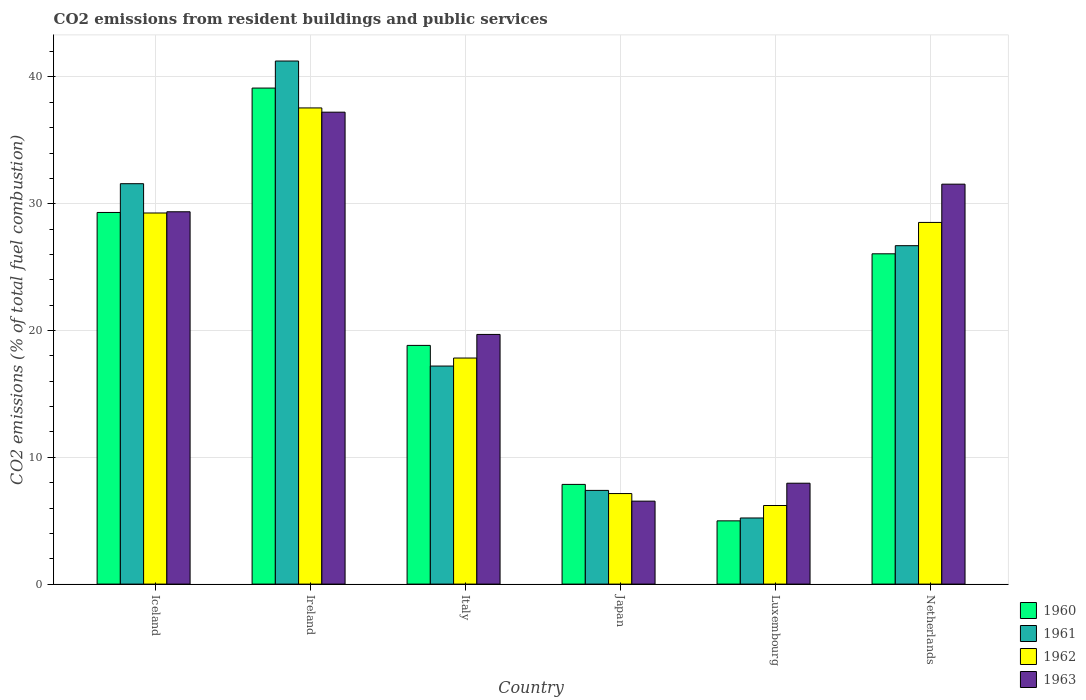How many different coloured bars are there?
Make the answer very short. 4. Are the number of bars per tick equal to the number of legend labels?
Keep it short and to the point. Yes. How many bars are there on the 4th tick from the left?
Provide a succinct answer. 4. What is the label of the 3rd group of bars from the left?
Your answer should be compact. Italy. What is the total CO2 emitted in 1960 in Luxembourg?
Your answer should be compact. 4.99. Across all countries, what is the maximum total CO2 emitted in 1961?
Make the answer very short. 41.25. Across all countries, what is the minimum total CO2 emitted in 1962?
Give a very brief answer. 6.2. In which country was the total CO2 emitted in 1963 maximum?
Offer a very short reply. Ireland. In which country was the total CO2 emitted in 1963 minimum?
Your answer should be compact. Japan. What is the total total CO2 emitted in 1962 in the graph?
Offer a very short reply. 126.52. What is the difference between the total CO2 emitted in 1962 in Iceland and that in Italy?
Your answer should be compact. 11.44. What is the difference between the total CO2 emitted in 1961 in Netherlands and the total CO2 emitted in 1962 in Luxembourg?
Ensure brevity in your answer.  20.49. What is the average total CO2 emitted in 1963 per country?
Make the answer very short. 22.05. What is the difference between the total CO2 emitted of/in 1963 and total CO2 emitted of/in 1960 in Netherlands?
Your answer should be very brief. 5.49. What is the ratio of the total CO2 emitted in 1961 in Ireland to that in Luxembourg?
Offer a terse response. 7.91. Is the difference between the total CO2 emitted in 1963 in Italy and Japan greater than the difference between the total CO2 emitted in 1960 in Italy and Japan?
Provide a succinct answer. Yes. What is the difference between the highest and the second highest total CO2 emitted in 1962?
Ensure brevity in your answer.  0.74. What is the difference between the highest and the lowest total CO2 emitted in 1962?
Your answer should be very brief. 31.36. In how many countries, is the total CO2 emitted in 1963 greater than the average total CO2 emitted in 1963 taken over all countries?
Offer a very short reply. 3. Is the sum of the total CO2 emitted in 1960 in Italy and Japan greater than the maximum total CO2 emitted in 1961 across all countries?
Make the answer very short. No. What does the 2nd bar from the right in Netherlands represents?
Offer a terse response. 1962. Are all the bars in the graph horizontal?
Offer a very short reply. No. How many countries are there in the graph?
Your response must be concise. 6. What is the difference between two consecutive major ticks on the Y-axis?
Your answer should be very brief. 10. Are the values on the major ticks of Y-axis written in scientific E-notation?
Keep it short and to the point. No. Does the graph contain any zero values?
Offer a terse response. No. Does the graph contain grids?
Your answer should be very brief. Yes. How many legend labels are there?
Keep it short and to the point. 4. How are the legend labels stacked?
Offer a very short reply. Vertical. What is the title of the graph?
Offer a terse response. CO2 emissions from resident buildings and public services. What is the label or title of the X-axis?
Offer a terse response. Country. What is the label or title of the Y-axis?
Make the answer very short. CO2 emissions (% of total fuel combustion). What is the CO2 emissions (% of total fuel combustion) of 1960 in Iceland?
Make the answer very short. 29.31. What is the CO2 emissions (% of total fuel combustion) in 1961 in Iceland?
Make the answer very short. 31.58. What is the CO2 emissions (% of total fuel combustion) in 1962 in Iceland?
Your response must be concise. 29.27. What is the CO2 emissions (% of total fuel combustion) of 1963 in Iceland?
Make the answer very short. 29.37. What is the CO2 emissions (% of total fuel combustion) of 1960 in Ireland?
Make the answer very short. 39.12. What is the CO2 emissions (% of total fuel combustion) of 1961 in Ireland?
Your response must be concise. 41.25. What is the CO2 emissions (% of total fuel combustion) of 1962 in Ireland?
Ensure brevity in your answer.  37.55. What is the CO2 emissions (% of total fuel combustion) in 1963 in Ireland?
Offer a very short reply. 37.22. What is the CO2 emissions (% of total fuel combustion) in 1960 in Italy?
Offer a terse response. 18.83. What is the CO2 emissions (% of total fuel combustion) in 1961 in Italy?
Keep it short and to the point. 17.2. What is the CO2 emissions (% of total fuel combustion) of 1962 in Italy?
Your answer should be compact. 17.83. What is the CO2 emissions (% of total fuel combustion) of 1963 in Italy?
Give a very brief answer. 19.69. What is the CO2 emissions (% of total fuel combustion) of 1960 in Japan?
Your response must be concise. 7.86. What is the CO2 emissions (% of total fuel combustion) in 1961 in Japan?
Ensure brevity in your answer.  7.39. What is the CO2 emissions (% of total fuel combustion) in 1962 in Japan?
Your answer should be very brief. 7.14. What is the CO2 emissions (% of total fuel combustion) in 1963 in Japan?
Give a very brief answer. 6.54. What is the CO2 emissions (% of total fuel combustion) of 1960 in Luxembourg?
Ensure brevity in your answer.  4.99. What is the CO2 emissions (% of total fuel combustion) of 1961 in Luxembourg?
Make the answer very short. 5.21. What is the CO2 emissions (% of total fuel combustion) of 1962 in Luxembourg?
Ensure brevity in your answer.  6.2. What is the CO2 emissions (% of total fuel combustion) in 1963 in Luxembourg?
Your response must be concise. 7.96. What is the CO2 emissions (% of total fuel combustion) of 1960 in Netherlands?
Provide a short and direct response. 26.05. What is the CO2 emissions (% of total fuel combustion) in 1961 in Netherlands?
Keep it short and to the point. 26.69. What is the CO2 emissions (% of total fuel combustion) of 1962 in Netherlands?
Provide a succinct answer. 28.52. What is the CO2 emissions (% of total fuel combustion) in 1963 in Netherlands?
Provide a succinct answer. 31.54. Across all countries, what is the maximum CO2 emissions (% of total fuel combustion) in 1960?
Your answer should be very brief. 39.12. Across all countries, what is the maximum CO2 emissions (% of total fuel combustion) in 1961?
Your answer should be compact. 41.25. Across all countries, what is the maximum CO2 emissions (% of total fuel combustion) in 1962?
Offer a terse response. 37.55. Across all countries, what is the maximum CO2 emissions (% of total fuel combustion) in 1963?
Your answer should be very brief. 37.22. Across all countries, what is the minimum CO2 emissions (% of total fuel combustion) in 1960?
Offer a very short reply. 4.99. Across all countries, what is the minimum CO2 emissions (% of total fuel combustion) in 1961?
Provide a short and direct response. 5.21. Across all countries, what is the minimum CO2 emissions (% of total fuel combustion) of 1962?
Ensure brevity in your answer.  6.2. Across all countries, what is the minimum CO2 emissions (% of total fuel combustion) in 1963?
Your response must be concise. 6.54. What is the total CO2 emissions (% of total fuel combustion) of 1960 in the graph?
Your answer should be very brief. 126.16. What is the total CO2 emissions (% of total fuel combustion) in 1961 in the graph?
Give a very brief answer. 129.33. What is the total CO2 emissions (% of total fuel combustion) in 1962 in the graph?
Your answer should be compact. 126.52. What is the total CO2 emissions (% of total fuel combustion) of 1963 in the graph?
Provide a succinct answer. 132.32. What is the difference between the CO2 emissions (% of total fuel combustion) in 1960 in Iceland and that in Ireland?
Your response must be concise. -9.81. What is the difference between the CO2 emissions (% of total fuel combustion) in 1961 in Iceland and that in Ireland?
Make the answer very short. -9.67. What is the difference between the CO2 emissions (% of total fuel combustion) of 1962 in Iceland and that in Ireland?
Your answer should be compact. -8.29. What is the difference between the CO2 emissions (% of total fuel combustion) in 1963 in Iceland and that in Ireland?
Offer a very short reply. -7.85. What is the difference between the CO2 emissions (% of total fuel combustion) in 1960 in Iceland and that in Italy?
Make the answer very short. 10.48. What is the difference between the CO2 emissions (% of total fuel combustion) in 1961 in Iceland and that in Italy?
Your answer should be compact. 14.38. What is the difference between the CO2 emissions (% of total fuel combustion) of 1962 in Iceland and that in Italy?
Your response must be concise. 11.44. What is the difference between the CO2 emissions (% of total fuel combustion) of 1963 in Iceland and that in Italy?
Your response must be concise. 9.67. What is the difference between the CO2 emissions (% of total fuel combustion) in 1960 in Iceland and that in Japan?
Ensure brevity in your answer.  21.45. What is the difference between the CO2 emissions (% of total fuel combustion) of 1961 in Iceland and that in Japan?
Give a very brief answer. 24.19. What is the difference between the CO2 emissions (% of total fuel combustion) of 1962 in Iceland and that in Japan?
Your answer should be compact. 22.13. What is the difference between the CO2 emissions (% of total fuel combustion) of 1963 in Iceland and that in Japan?
Offer a terse response. 22.82. What is the difference between the CO2 emissions (% of total fuel combustion) in 1960 in Iceland and that in Luxembourg?
Your answer should be compact. 24.32. What is the difference between the CO2 emissions (% of total fuel combustion) of 1961 in Iceland and that in Luxembourg?
Give a very brief answer. 26.36. What is the difference between the CO2 emissions (% of total fuel combustion) in 1962 in Iceland and that in Luxembourg?
Offer a terse response. 23.07. What is the difference between the CO2 emissions (% of total fuel combustion) of 1963 in Iceland and that in Luxembourg?
Offer a terse response. 21.41. What is the difference between the CO2 emissions (% of total fuel combustion) of 1960 in Iceland and that in Netherlands?
Give a very brief answer. 3.26. What is the difference between the CO2 emissions (% of total fuel combustion) of 1961 in Iceland and that in Netherlands?
Your answer should be compact. 4.89. What is the difference between the CO2 emissions (% of total fuel combustion) in 1962 in Iceland and that in Netherlands?
Make the answer very short. 0.74. What is the difference between the CO2 emissions (% of total fuel combustion) in 1963 in Iceland and that in Netherlands?
Your answer should be very brief. -2.18. What is the difference between the CO2 emissions (% of total fuel combustion) in 1960 in Ireland and that in Italy?
Your response must be concise. 20.29. What is the difference between the CO2 emissions (% of total fuel combustion) in 1961 in Ireland and that in Italy?
Keep it short and to the point. 24.06. What is the difference between the CO2 emissions (% of total fuel combustion) of 1962 in Ireland and that in Italy?
Ensure brevity in your answer.  19.73. What is the difference between the CO2 emissions (% of total fuel combustion) of 1963 in Ireland and that in Italy?
Your answer should be very brief. 17.53. What is the difference between the CO2 emissions (% of total fuel combustion) in 1960 in Ireland and that in Japan?
Provide a short and direct response. 31.26. What is the difference between the CO2 emissions (% of total fuel combustion) in 1961 in Ireland and that in Japan?
Ensure brevity in your answer.  33.86. What is the difference between the CO2 emissions (% of total fuel combustion) of 1962 in Ireland and that in Japan?
Offer a very short reply. 30.41. What is the difference between the CO2 emissions (% of total fuel combustion) in 1963 in Ireland and that in Japan?
Your response must be concise. 30.68. What is the difference between the CO2 emissions (% of total fuel combustion) in 1960 in Ireland and that in Luxembourg?
Ensure brevity in your answer.  34.13. What is the difference between the CO2 emissions (% of total fuel combustion) of 1961 in Ireland and that in Luxembourg?
Offer a terse response. 36.04. What is the difference between the CO2 emissions (% of total fuel combustion) in 1962 in Ireland and that in Luxembourg?
Offer a very short reply. 31.36. What is the difference between the CO2 emissions (% of total fuel combustion) of 1963 in Ireland and that in Luxembourg?
Provide a short and direct response. 29.26. What is the difference between the CO2 emissions (% of total fuel combustion) in 1960 in Ireland and that in Netherlands?
Give a very brief answer. 13.07. What is the difference between the CO2 emissions (% of total fuel combustion) in 1961 in Ireland and that in Netherlands?
Your response must be concise. 14.56. What is the difference between the CO2 emissions (% of total fuel combustion) of 1962 in Ireland and that in Netherlands?
Make the answer very short. 9.03. What is the difference between the CO2 emissions (% of total fuel combustion) in 1963 in Ireland and that in Netherlands?
Provide a short and direct response. 5.68. What is the difference between the CO2 emissions (% of total fuel combustion) in 1960 in Italy and that in Japan?
Give a very brief answer. 10.96. What is the difference between the CO2 emissions (% of total fuel combustion) in 1961 in Italy and that in Japan?
Give a very brief answer. 9.81. What is the difference between the CO2 emissions (% of total fuel combustion) in 1962 in Italy and that in Japan?
Your answer should be compact. 10.69. What is the difference between the CO2 emissions (% of total fuel combustion) of 1963 in Italy and that in Japan?
Give a very brief answer. 13.15. What is the difference between the CO2 emissions (% of total fuel combustion) in 1960 in Italy and that in Luxembourg?
Keep it short and to the point. 13.84. What is the difference between the CO2 emissions (% of total fuel combustion) in 1961 in Italy and that in Luxembourg?
Provide a succinct answer. 11.98. What is the difference between the CO2 emissions (% of total fuel combustion) in 1962 in Italy and that in Luxembourg?
Ensure brevity in your answer.  11.63. What is the difference between the CO2 emissions (% of total fuel combustion) in 1963 in Italy and that in Luxembourg?
Provide a succinct answer. 11.73. What is the difference between the CO2 emissions (% of total fuel combustion) in 1960 in Italy and that in Netherlands?
Give a very brief answer. -7.22. What is the difference between the CO2 emissions (% of total fuel combustion) of 1961 in Italy and that in Netherlands?
Give a very brief answer. -9.49. What is the difference between the CO2 emissions (% of total fuel combustion) in 1962 in Italy and that in Netherlands?
Offer a terse response. -10.7. What is the difference between the CO2 emissions (% of total fuel combustion) in 1963 in Italy and that in Netherlands?
Your response must be concise. -11.85. What is the difference between the CO2 emissions (% of total fuel combustion) in 1960 in Japan and that in Luxembourg?
Your answer should be compact. 2.87. What is the difference between the CO2 emissions (% of total fuel combustion) in 1961 in Japan and that in Luxembourg?
Offer a terse response. 2.18. What is the difference between the CO2 emissions (% of total fuel combustion) of 1962 in Japan and that in Luxembourg?
Offer a very short reply. 0.94. What is the difference between the CO2 emissions (% of total fuel combustion) in 1963 in Japan and that in Luxembourg?
Offer a very short reply. -1.41. What is the difference between the CO2 emissions (% of total fuel combustion) in 1960 in Japan and that in Netherlands?
Offer a terse response. -18.19. What is the difference between the CO2 emissions (% of total fuel combustion) of 1961 in Japan and that in Netherlands?
Give a very brief answer. -19.3. What is the difference between the CO2 emissions (% of total fuel combustion) of 1962 in Japan and that in Netherlands?
Offer a very short reply. -21.38. What is the difference between the CO2 emissions (% of total fuel combustion) in 1963 in Japan and that in Netherlands?
Offer a terse response. -25. What is the difference between the CO2 emissions (% of total fuel combustion) of 1960 in Luxembourg and that in Netherlands?
Your answer should be very brief. -21.06. What is the difference between the CO2 emissions (% of total fuel combustion) in 1961 in Luxembourg and that in Netherlands?
Give a very brief answer. -21.48. What is the difference between the CO2 emissions (% of total fuel combustion) in 1962 in Luxembourg and that in Netherlands?
Your answer should be very brief. -22.33. What is the difference between the CO2 emissions (% of total fuel combustion) of 1963 in Luxembourg and that in Netherlands?
Provide a succinct answer. -23.58. What is the difference between the CO2 emissions (% of total fuel combustion) in 1960 in Iceland and the CO2 emissions (% of total fuel combustion) in 1961 in Ireland?
Make the answer very short. -11.94. What is the difference between the CO2 emissions (% of total fuel combustion) in 1960 in Iceland and the CO2 emissions (% of total fuel combustion) in 1962 in Ireland?
Offer a very short reply. -8.24. What is the difference between the CO2 emissions (% of total fuel combustion) in 1960 in Iceland and the CO2 emissions (% of total fuel combustion) in 1963 in Ireland?
Your answer should be compact. -7.91. What is the difference between the CO2 emissions (% of total fuel combustion) of 1961 in Iceland and the CO2 emissions (% of total fuel combustion) of 1962 in Ireland?
Offer a terse response. -5.98. What is the difference between the CO2 emissions (% of total fuel combustion) of 1961 in Iceland and the CO2 emissions (% of total fuel combustion) of 1963 in Ireland?
Offer a terse response. -5.64. What is the difference between the CO2 emissions (% of total fuel combustion) in 1962 in Iceland and the CO2 emissions (% of total fuel combustion) in 1963 in Ireland?
Ensure brevity in your answer.  -7.95. What is the difference between the CO2 emissions (% of total fuel combustion) of 1960 in Iceland and the CO2 emissions (% of total fuel combustion) of 1961 in Italy?
Your answer should be compact. 12.11. What is the difference between the CO2 emissions (% of total fuel combustion) of 1960 in Iceland and the CO2 emissions (% of total fuel combustion) of 1962 in Italy?
Provide a short and direct response. 11.48. What is the difference between the CO2 emissions (% of total fuel combustion) in 1960 in Iceland and the CO2 emissions (% of total fuel combustion) in 1963 in Italy?
Offer a very short reply. 9.62. What is the difference between the CO2 emissions (% of total fuel combustion) of 1961 in Iceland and the CO2 emissions (% of total fuel combustion) of 1962 in Italy?
Provide a succinct answer. 13.75. What is the difference between the CO2 emissions (% of total fuel combustion) in 1961 in Iceland and the CO2 emissions (% of total fuel combustion) in 1963 in Italy?
Offer a terse response. 11.89. What is the difference between the CO2 emissions (% of total fuel combustion) of 1962 in Iceland and the CO2 emissions (% of total fuel combustion) of 1963 in Italy?
Your answer should be compact. 9.58. What is the difference between the CO2 emissions (% of total fuel combustion) of 1960 in Iceland and the CO2 emissions (% of total fuel combustion) of 1961 in Japan?
Offer a terse response. 21.92. What is the difference between the CO2 emissions (% of total fuel combustion) of 1960 in Iceland and the CO2 emissions (% of total fuel combustion) of 1962 in Japan?
Offer a terse response. 22.17. What is the difference between the CO2 emissions (% of total fuel combustion) of 1960 in Iceland and the CO2 emissions (% of total fuel combustion) of 1963 in Japan?
Your answer should be very brief. 22.77. What is the difference between the CO2 emissions (% of total fuel combustion) in 1961 in Iceland and the CO2 emissions (% of total fuel combustion) in 1962 in Japan?
Keep it short and to the point. 24.44. What is the difference between the CO2 emissions (% of total fuel combustion) in 1961 in Iceland and the CO2 emissions (% of total fuel combustion) in 1963 in Japan?
Keep it short and to the point. 25.04. What is the difference between the CO2 emissions (% of total fuel combustion) in 1962 in Iceland and the CO2 emissions (% of total fuel combustion) in 1963 in Japan?
Your response must be concise. 22.73. What is the difference between the CO2 emissions (% of total fuel combustion) of 1960 in Iceland and the CO2 emissions (% of total fuel combustion) of 1961 in Luxembourg?
Ensure brevity in your answer.  24.1. What is the difference between the CO2 emissions (% of total fuel combustion) of 1960 in Iceland and the CO2 emissions (% of total fuel combustion) of 1962 in Luxembourg?
Provide a succinct answer. 23.11. What is the difference between the CO2 emissions (% of total fuel combustion) in 1960 in Iceland and the CO2 emissions (% of total fuel combustion) in 1963 in Luxembourg?
Offer a very short reply. 21.35. What is the difference between the CO2 emissions (% of total fuel combustion) in 1961 in Iceland and the CO2 emissions (% of total fuel combustion) in 1962 in Luxembourg?
Offer a terse response. 25.38. What is the difference between the CO2 emissions (% of total fuel combustion) in 1961 in Iceland and the CO2 emissions (% of total fuel combustion) in 1963 in Luxembourg?
Your response must be concise. 23.62. What is the difference between the CO2 emissions (% of total fuel combustion) in 1962 in Iceland and the CO2 emissions (% of total fuel combustion) in 1963 in Luxembourg?
Keep it short and to the point. 21.31. What is the difference between the CO2 emissions (% of total fuel combustion) of 1960 in Iceland and the CO2 emissions (% of total fuel combustion) of 1961 in Netherlands?
Provide a short and direct response. 2.62. What is the difference between the CO2 emissions (% of total fuel combustion) of 1960 in Iceland and the CO2 emissions (% of total fuel combustion) of 1962 in Netherlands?
Your answer should be very brief. 0.79. What is the difference between the CO2 emissions (% of total fuel combustion) of 1960 in Iceland and the CO2 emissions (% of total fuel combustion) of 1963 in Netherlands?
Provide a short and direct response. -2.23. What is the difference between the CO2 emissions (% of total fuel combustion) of 1961 in Iceland and the CO2 emissions (% of total fuel combustion) of 1962 in Netherlands?
Offer a very short reply. 3.05. What is the difference between the CO2 emissions (% of total fuel combustion) of 1961 in Iceland and the CO2 emissions (% of total fuel combustion) of 1963 in Netherlands?
Your answer should be compact. 0.04. What is the difference between the CO2 emissions (% of total fuel combustion) in 1962 in Iceland and the CO2 emissions (% of total fuel combustion) in 1963 in Netherlands?
Offer a terse response. -2.27. What is the difference between the CO2 emissions (% of total fuel combustion) in 1960 in Ireland and the CO2 emissions (% of total fuel combustion) in 1961 in Italy?
Your response must be concise. 21.92. What is the difference between the CO2 emissions (% of total fuel combustion) of 1960 in Ireland and the CO2 emissions (% of total fuel combustion) of 1962 in Italy?
Make the answer very short. 21.29. What is the difference between the CO2 emissions (% of total fuel combustion) of 1960 in Ireland and the CO2 emissions (% of total fuel combustion) of 1963 in Italy?
Provide a short and direct response. 19.43. What is the difference between the CO2 emissions (% of total fuel combustion) in 1961 in Ireland and the CO2 emissions (% of total fuel combustion) in 1962 in Italy?
Provide a short and direct response. 23.42. What is the difference between the CO2 emissions (% of total fuel combustion) of 1961 in Ireland and the CO2 emissions (% of total fuel combustion) of 1963 in Italy?
Ensure brevity in your answer.  21.56. What is the difference between the CO2 emissions (% of total fuel combustion) in 1962 in Ireland and the CO2 emissions (% of total fuel combustion) in 1963 in Italy?
Keep it short and to the point. 17.86. What is the difference between the CO2 emissions (% of total fuel combustion) in 1960 in Ireland and the CO2 emissions (% of total fuel combustion) in 1961 in Japan?
Offer a very short reply. 31.73. What is the difference between the CO2 emissions (% of total fuel combustion) of 1960 in Ireland and the CO2 emissions (% of total fuel combustion) of 1962 in Japan?
Keep it short and to the point. 31.98. What is the difference between the CO2 emissions (% of total fuel combustion) of 1960 in Ireland and the CO2 emissions (% of total fuel combustion) of 1963 in Japan?
Give a very brief answer. 32.58. What is the difference between the CO2 emissions (% of total fuel combustion) in 1961 in Ireland and the CO2 emissions (% of total fuel combustion) in 1962 in Japan?
Provide a succinct answer. 34.11. What is the difference between the CO2 emissions (% of total fuel combustion) in 1961 in Ireland and the CO2 emissions (% of total fuel combustion) in 1963 in Japan?
Ensure brevity in your answer.  34.71. What is the difference between the CO2 emissions (% of total fuel combustion) in 1962 in Ireland and the CO2 emissions (% of total fuel combustion) in 1963 in Japan?
Your answer should be very brief. 31.01. What is the difference between the CO2 emissions (% of total fuel combustion) of 1960 in Ireland and the CO2 emissions (% of total fuel combustion) of 1961 in Luxembourg?
Ensure brevity in your answer.  33.91. What is the difference between the CO2 emissions (% of total fuel combustion) in 1960 in Ireland and the CO2 emissions (% of total fuel combustion) in 1962 in Luxembourg?
Provide a short and direct response. 32.92. What is the difference between the CO2 emissions (% of total fuel combustion) of 1960 in Ireland and the CO2 emissions (% of total fuel combustion) of 1963 in Luxembourg?
Your response must be concise. 31.16. What is the difference between the CO2 emissions (% of total fuel combustion) of 1961 in Ireland and the CO2 emissions (% of total fuel combustion) of 1962 in Luxembourg?
Give a very brief answer. 35.06. What is the difference between the CO2 emissions (% of total fuel combustion) in 1961 in Ireland and the CO2 emissions (% of total fuel combustion) in 1963 in Luxembourg?
Provide a short and direct response. 33.3. What is the difference between the CO2 emissions (% of total fuel combustion) in 1962 in Ireland and the CO2 emissions (% of total fuel combustion) in 1963 in Luxembourg?
Ensure brevity in your answer.  29.6. What is the difference between the CO2 emissions (% of total fuel combustion) in 1960 in Ireland and the CO2 emissions (% of total fuel combustion) in 1961 in Netherlands?
Give a very brief answer. 12.43. What is the difference between the CO2 emissions (% of total fuel combustion) in 1960 in Ireland and the CO2 emissions (% of total fuel combustion) in 1962 in Netherlands?
Your response must be concise. 10.6. What is the difference between the CO2 emissions (% of total fuel combustion) in 1960 in Ireland and the CO2 emissions (% of total fuel combustion) in 1963 in Netherlands?
Offer a terse response. 7.58. What is the difference between the CO2 emissions (% of total fuel combustion) in 1961 in Ireland and the CO2 emissions (% of total fuel combustion) in 1962 in Netherlands?
Offer a terse response. 12.73. What is the difference between the CO2 emissions (% of total fuel combustion) in 1961 in Ireland and the CO2 emissions (% of total fuel combustion) in 1963 in Netherlands?
Offer a terse response. 9.71. What is the difference between the CO2 emissions (% of total fuel combustion) of 1962 in Ireland and the CO2 emissions (% of total fuel combustion) of 1963 in Netherlands?
Make the answer very short. 6.01. What is the difference between the CO2 emissions (% of total fuel combustion) of 1960 in Italy and the CO2 emissions (% of total fuel combustion) of 1961 in Japan?
Your response must be concise. 11.43. What is the difference between the CO2 emissions (% of total fuel combustion) of 1960 in Italy and the CO2 emissions (% of total fuel combustion) of 1962 in Japan?
Ensure brevity in your answer.  11.68. What is the difference between the CO2 emissions (% of total fuel combustion) in 1960 in Italy and the CO2 emissions (% of total fuel combustion) in 1963 in Japan?
Offer a terse response. 12.28. What is the difference between the CO2 emissions (% of total fuel combustion) in 1961 in Italy and the CO2 emissions (% of total fuel combustion) in 1962 in Japan?
Your answer should be very brief. 10.05. What is the difference between the CO2 emissions (% of total fuel combustion) in 1961 in Italy and the CO2 emissions (% of total fuel combustion) in 1963 in Japan?
Make the answer very short. 10.65. What is the difference between the CO2 emissions (% of total fuel combustion) of 1962 in Italy and the CO2 emissions (% of total fuel combustion) of 1963 in Japan?
Your response must be concise. 11.29. What is the difference between the CO2 emissions (% of total fuel combustion) of 1960 in Italy and the CO2 emissions (% of total fuel combustion) of 1961 in Luxembourg?
Offer a terse response. 13.61. What is the difference between the CO2 emissions (% of total fuel combustion) in 1960 in Italy and the CO2 emissions (% of total fuel combustion) in 1962 in Luxembourg?
Make the answer very short. 12.63. What is the difference between the CO2 emissions (% of total fuel combustion) of 1960 in Italy and the CO2 emissions (% of total fuel combustion) of 1963 in Luxembourg?
Your answer should be very brief. 10.87. What is the difference between the CO2 emissions (% of total fuel combustion) in 1961 in Italy and the CO2 emissions (% of total fuel combustion) in 1962 in Luxembourg?
Your answer should be very brief. 11. What is the difference between the CO2 emissions (% of total fuel combustion) in 1961 in Italy and the CO2 emissions (% of total fuel combustion) in 1963 in Luxembourg?
Your response must be concise. 9.24. What is the difference between the CO2 emissions (% of total fuel combustion) of 1962 in Italy and the CO2 emissions (% of total fuel combustion) of 1963 in Luxembourg?
Make the answer very short. 9.87. What is the difference between the CO2 emissions (% of total fuel combustion) of 1960 in Italy and the CO2 emissions (% of total fuel combustion) of 1961 in Netherlands?
Your answer should be very brief. -7.86. What is the difference between the CO2 emissions (% of total fuel combustion) in 1960 in Italy and the CO2 emissions (% of total fuel combustion) in 1962 in Netherlands?
Your response must be concise. -9.7. What is the difference between the CO2 emissions (% of total fuel combustion) in 1960 in Italy and the CO2 emissions (% of total fuel combustion) in 1963 in Netherlands?
Provide a succinct answer. -12.72. What is the difference between the CO2 emissions (% of total fuel combustion) of 1961 in Italy and the CO2 emissions (% of total fuel combustion) of 1962 in Netherlands?
Offer a very short reply. -11.33. What is the difference between the CO2 emissions (% of total fuel combustion) of 1961 in Italy and the CO2 emissions (% of total fuel combustion) of 1963 in Netherlands?
Your response must be concise. -14.35. What is the difference between the CO2 emissions (% of total fuel combustion) in 1962 in Italy and the CO2 emissions (% of total fuel combustion) in 1963 in Netherlands?
Ensure brevity in your answer.  -13.71. What is the difference between the CO2 emissions (% of total fuel combustion) in 1960 in Japan and the CO2 emissions (% of total fuel combustion) in 1961 in Luxembourg?
Provide a short and direct response. 2.65. What is the difference between the CO2 emissions (% of total fuel combustion) of 1960 in Japan and the CO2 emissions (% of total fuel combustion) of 1962 in Luxembourg?
Ensure brevity in your answer.  1.66. What is the difference between the CO2 emissions (% of total fuel combustion) of 1960 in Japan and the CO2 emissions (% of total fuel combustion) of 1963 in Luxembourg?
Offer a terse response. -0.09. What is the difference between the CO2 emissions (% of total fuel combustion) of 1961 in Japan and the CO2 emissions (% of total fuel combustion) of 1962 in Luxembourg?
Your answer should be very brief. 1.19. What is the difference between the CO2 emissions (% of total fuel combustion) in 1961 in Japan and the CO2 emissions (% of total fuel combustion) in 1963 in Luxembourg?
Your response must be concise. -0.57. What is the difference between the CO2 emissions (% of total fuel combustion) of 1962 in Japan and the CO2 emissions (% of total fuel combustion) of 1963 in Luxembourg?
Provide a short and direct response. -0.82. What is the difference between the CO2 emissions (% of total fuel combustion) in 1960 in Japan and the CO2 emissions (% of total fuel combustion) in 1961 in Netherlands?
Provide a short and direct response. -18.83. What is the difference between the CO2 emissions (% of total fuel combustion) in 1960 in Japan and the CO2 emissions (% of total fuel combustion) in 1962 in Netherlands?
Make the answer very short. -20.66. What is the difference between the CO2 emissions (% of total fuel combustion) in 1960 in Japan and the CO2 emissions (% of total fuel combustion) in 1963 in Netherlands?
Ensure brevity in your answer.  -23.68. What is the difference between the CO2 emissions (% of total fuel combustion) in 1961 in Japan and the CO2 emissions (% of total fuel combustion) in 1962 in Netherlands?
Ensure brevity in your answer.  -21.13. What is the difference between the CO2 emissions (% of total fuel combustion) of 1961 in Japan and the CO2 emissions (% of total fuel combustion) of 1963 in Netherlands?
Your answer should be compact. -24.15. What is the difference between the CO2 emissions (% of total fuel combustion) of 1962 in Japan and the CO2 emissions (% of total fuel combustion) of 1963 in Netherlands?
Offer a terse response. -24.4. What is the difference between the CO2 emissions (% of total fuel combustion) in 1960 in Luxembourg and the CO2 emissions (% of total fuel combustion) in 1961 in Netherlands?
Your response must be concise. -21.7. What is the difference between the CO2 emissions (% of total fuel combustion) of 1960 in Luxembourg and the CO2 emissions (% of total fuel combustion) of 1962 in Netherlands?
Your answer should be compact. -23.54. What is the difference between the CO2 emissions (% of total fuel combustion) in 1960 in Luxembourg and the CO2 emissions (% of total fuel combustion) in 1963 in Netherlands?
Your answer should be compact. -26.55. What is the difference between the CO2 emissions (% of total fuel combustion) of 1961 in Luxembourg and the CO2 emissions (% of total fuel combustion) of 1962 in Netherlands?
Provide a succinct answer. -23.31. What is the difference between the CO2 emissions (% of total fuel combustion) in 1961 in Luxembourg and the CO2 emissions (% of total fuel combustion) in 1963 in Netherlands?
Provide a short and direct response. -26.33. What is the difference between the CO2 emissions (% of total fuel combustion) of 1962 in Luxembourg and the CO2 emissions (% of total fuel combustion) of 1963 in Netherlands?
Provide a short and direct response. -25.34. What is the average CO2 emissions (% of total fuel combustion) in 1960 per country?
Your answer should be compact. 21.03. What is the average CO2 emissions (% of total fuel combustion) in 1961 per country?
Keep it short and to the point. 21.55. What is the average CO2 emissions (% of total fuel combustion) in 1962 per country?
Ensure brevity in your answer.  21.09. What is the average CO2 emissions (% of total fuel combustion) of 1963 per country?
Keep it short and to the point. 22.05. What is the difference between the CO2 emissions (% of total fuel combustion) of 1960 and CO2 emissions (% of total fuel combustion) of 1961 in Iceland?
Keep it short and to the point. -2.27. What is the difference between the CO2 emissions (% of total fuel combustion) of 1960 and CO2 emissions (% of total fuel combustion) of 1962 in Iceland?
Provide a succinct answer. 0.04. What is the difference between the CO2 emissions (% of total fuel combustion) in 1960 and CO2 emissions (% of total fuel combustion) in 1963 in Iceland?
Provide a short and direct response. -0.05. What is the difference between the CO2 emissions (% of total fuel combustion) of 1961 and CO2 emissions (% of total fuel combustion) of 1962 in Iceland?
Make the answer very short. 2.31. What is the difference between the CO2 emissions (% of total fuel combustion) in 1961 and CO2 emissions (% of total fuel combustion) in 1963 in Iceland?
Provide a succinct answer. 2.21. What is the difference between the CO2 emissions (% of total fuel combustion) in 1962 and CO2 emissions (% of total fuel combustion) in 1963 in Iceland?
Provide a succinct answer. -0.1. What is the difference between the CO2 emissions (% of total fuel combustion) in 1960 and CO2 emissions (% of total fuel combustion) in 1961 in Ireland?
Make the answer very short. -2.13. What is the difference between the CO2 emissions (% of total fuel combustion) of 1960 and CO2 emissions (% of total fuel combustion) of 1962 in Ireland?
Offer a very short reply. 1.57. What is the difference between the CO2 emissions (% of total fuel combustion) of 1960 and CO2 emissions (% of total fuel combustion) of 1963 in Ireland?
Offer a terse response. 1.9. What is the difference between the CO2 emissions (% of total fuel combustion) in 1961 and CO2 emissions (% of total fuel combustion) in 1962 in Ireland?
Your answer should be compact. 3.7. What is the difference between the CO2 emissions (% of total fuel combustion) of 1961 and CO2 emissions (% of total fuel combustion) of 1963 in Ireland?
Your response must be concise. 4.03. What is the difference between the CO2 emissions (% of total fuel combustion) of 1962 and CO2 emissions (% of total fuel combustion) of 1963 in Ireland?
Provide a short and direct response. 0.34. What is the difference between the CO2 emissions (% of total fuel combustion) of 1960 and CO2 emissions (% of total fuel combustion) of 1961 in Italy?
Give a very brief answer. 1.63. What is the difference between the CO2 emissions (% of total fuel combustion) in 1960 and CO2 emissions (% of total fuel combustion) in 1963 in Italy?
Your response must be concise. -0.87. What is the difference between the CO2 emissions (% of total fuel combustion) in 1961 and CO2 emissions (% of total fuel combustion) in 1962 in Italy?
Provide a short and direct response. -0.63. What is the difference between the CO2 emissions (% of total fuel combustion) of 1961 and CO2 emissions (% of total fuel combustion) of 1963 in Italy?
Provide a short and direct response. -2.49. What is the difference between the CO2 emissions (% of total fuel combustion) in 1962 and CO2 emissions (% of total fuel combustion) in 1963 in Italy?
Provide a succinct answer. -1.86. What is the difference between the CO2 emissions (% of total fuel combustion) of 1960 and CO2 emissions (% of total fuel combustion) of 1961 in Japan?
Give a very brief answer. 0.47. What is the difference between the CO2 emissions (% of total fuel combustion) in 1960 and CO2 emissions (% of total fuel combustion) in 1962 in Japan?
Make the answer very short. 0.72. What is the difference between the CO2 emissions (% of total fuel combustion) in 1960 and CO2 emissions (% of total fuel combustion) in 1963 in Japan?
Keep it short and to the point. 1.32. What is the difference between the CO2 emissions (% of total fuel combustion) in 1961 and CO2 emissions (% of total fuel combustion) in 1962 in Japan?
Keep it short and to the point. 0.25. What is the difference between the CO2 emissions (% of total fuel combustion) in 1961 and CO2 emissions (% of total fuel combustion) in 1963 in Japan?
Your response must be concise. 0.85. What is the difference between the CO2 emissions (% of total fuel combustion) of 1962 and CO2 emissions (% of total fuel combustion) of 1963 in Japan?
Your answer should be compact. 0.6. What is the difference between the CO2 emissions (% of total fuel combustion) of 1960 and CO2 emissions (% of total fuel combustion) of 1961 in Luxembourg?
Your response must be concise. -0.23. What is the difference between the CO2 emissions (% of total fuel combustion) of 1960 and CO2 emissions (% of total fuel combustion) of 1962 in Luxembourg?
Your response must be concise. -1.21. What is the difference between the CO2 emissions (% of total fuel combustion) in 1960 and CO2 emissions (% of total fuel combustion) in 1963 in Luxembourg?
Your answer should be compact. -2.97. What is the difference between the CO2 emissions (% of total fuel combustion) of 1961 and CO2 emissions (% of total fuel combustion) of 1962 in Luxembourg?
Your response must be concise. -0.98. What is the difference between the CO2 emissions (% of total fuel combustion) of 1961 and CO2 emissions (% of total fuel combustion) of 1963 in Luxembourg?
Give a very brief answer. -2.74. What is the difference between the CO2 emissions (% of total fuel combustion) in 1962 and CO2 emissions (% of total fuel combustion) in 1963 in Luxembourg?
Offer a very short reply. -1.76. What is the difference between the CO2 emissions (% of total fuel combustion) of 1960 and CO2 emissions (% of total fuel combustion) of 1961 in Netherlands?
Ensure brevity in your answer.  -0.64. What is the difference between the CO2 emissions (% of total fuel combustion) of 1960 and CO2 emissions (% of total fuel combustion) of 1962 in Netherlands?
Provide a short and direct response. -2.47. What is the difference between the CO2 emissions (% of total fuel combustion) in 1960 and CO2 emissions (% of total fuel combustion) in 1963 in Netherlands?
Make the answer very short. -5.49. What is the difference between the CO2 emissions (% of total fuel combustion) in 1961 and CO2 emissions (% of total fuel combustion) in 1962 in Netherlands?
Make the answer very short. -1.83. What is the difference between the CO2 emissions (% of total fuel combustion) in 1961 and CO2 emissions (% of total fuel combustion) in 1963 in Netherlands?
Offer a terse response. -4.85. What is the difference between the CO2 emissions (% of total fuel combustion) in 1962 and CO2 emissions (% of total fuel combustion) in 1963 in Netherlands?
Make the answer very short. -3.02. What is the ratio of the CO2 emissions (% of total fuel combustion) in 1960 in Iceland to that in Ireland?
Ensure brevity in your answer.  0.75. What is the ratio of the CO2 emissions (% of total fuel combustion) of 1961 in Iceland to that in Ireland?
Provide a short and direct response. 0.77. What is the ratio of the CO2 emissions (% of total fuel combustion) in 1962 in Iceland to that in Ireland?
Offer a very short reply. 0.78. What is the ratio of the CO2 emissions (% of total fuel combustion) of 1963 in Iceland to that in Ireland?
Provide a short and direct response. 0.79. What is the ratio of the CO2 emissions (% of total fuel combustion) of 1960 in Iceland to that in Italy?
Your answer should be compact. 1.56. What is the ratio of the CO2 emissions (% of total fuel combustion) of 1961 in Iceland to that in Italy?
Offer a very short reply. 1.84. What is the ratio of the CO2 emissions (% of total fuel combustion) in 1962 in Iceland to that in Italy?
Your answer should be compact. 1.64. What is the ratio of the CO2 emissions (% of total fuel combustion) in 1963 in Iceland to that in Italy?
Your answer should be compact. 1.49. What is the ratio of the CO2 emissions (% of total fuel combustion) of 1960 in Iceland to that in Japan?
Ensure brevity in your answer.  3.73. What is the ratio of the CO2 emissions (% of total fuel combustion) in 1961 in Iceland to that in Japan?
Offer a very short reply. 4.27. What is the ratio of the CO2 emissions (% of total fuel combustion) of 1962 in Iceland to that in Japan?
Provide a short and direct response. 4.1. What is the ratio of the CO2 emissions (% of total fuel combustion) in 1963 in Iceland to that in Japan?
Provide a short and direct response. 4.49. What is the ratio of the CO2 emissions (% of total fuel combustion) in 1960 in Iceland to that in Luxembourg?
Your response must be concise. 5.88. What is the ratio of the CO2 emissions (% of total fuel combustion) of 1961 in Iceland to that in Luxembourg?
Offer a very short reply. 6.06. What is the ratio of the CO2 emissions (% of total fuel combustion) of 1962 in Iceland to that in Luxembourg?
Give a very brief answer. 4.72. What is the ratio of the CO2 emissions (% of total fuel combustion) in 1963 in Iceland to that in Luxembourg?
Offer a very short reply. 3.69. What is the ratio of the CO2 emissions (% of total fuel combustion) of 1960 in Iceland to that in Netherlands?
Your answer should be compact. 1.13. What is the ratio of the CO2 emissions (% of total fuel combustion) in 1961 in Iceland to that in Netherlands?
Offer a very short reply. 1.18. What is the ratio of the CO2 emissions (% of total fuel combustion) in 1962 in Iceland to that in Netherlands?
Your answer should be very brief. 1.03. What is the ratio of the CO2 emissions (% of total fuel combustion) in 1960 in Ireland to that in Italy?
Ensure brevity in your answer.  2.08. What is the ratio of the CO2 emissions (% of total fuel combustion) in 1961 in Ireland to that in Italy?
Ensure brevity in your answer.  2.4. What is the ratio of the CO2 emissions (% of total fuel combustion) of 1962 in Ireland to that in Italy?
Provide a short and direct response. 2.11. What is the ratio of the CO2 emissions (% of total fuel combustion) in 1963 in Ireland to that in Italy?
Your response must be concise. 1.89. What is the ratio of the CO2 emissions (% of total fuel combustion) of 1960 in Ireland to that in Japan?
Your answer should be very brief. 4.98. What is the ratio of the CO2 emissions (% of total fuel combustion) in 1961 in Ireland to that in Japan?
Provide a succinct answer. 5.58. What is the ratio of the CO2 emissions (% of total fuel combustion) of 1962 in Ireland to that in Japan?
Your answer should be very brief. 5.26. What is the ratio of the CO2 emissions (% of total fuel combustion) of 1963 in Ireland to that in Japan?
Your answer should be compact. 5.69. What is the ratio of the CO2 emissions (% of total fuel combustion) of 1960 in Ireland to that in Luxembourg?
Offer a terse response. 7.84. What is the ratio of the CO2 emissions (% of total fuel combustion) in 1961 in Ireland to that in Luxembourg?
Make the answer very short. 7.91. What is the ratio of the CO2 emissions (% of total fuel combustion) of 1962 in Ireland to that in Luxembourg?
Offer a very short reply. 6.06. What is the ratio of the CO2 emissions (% of total fuel combustion) of 1963 in Ireland to that in Luxembourg?
Your answer should be very brief. 4.68. What is the ratio of the CO2 emissions (% of total fuel combustion) in 1960 in Ireland to that in Netherlands?
Ensure brevity in your answer.  1.5. What is the ratio of the CO2 emissions (% of total fuel combustion) in 1961 in Ireland to that in Netherlands?
Provide a succinct answer. 1.55. What is the ratio of the CO2 emissions (% of total fuel combustion) of 1962 in Ireland to that in Netherlands?
Make the answer very short. 1.32. What is the ratio of the CO2 emissions (% of total fuel combustion) in 1963 in Ireland to that in Netherlands?
Ensure brevity in your answer.  1.18. What is the ratio of the CO2 emissions (% of total fuel combustion) in 1960 in Italy to that in Japan?
Offer a very short reply. 2.39. What is the ratio of the CO2 emissions (% of total fuel combustion) of 1961 in Italy to that in Japan?
Make the answer very short. 2.33. What is the ratio of the CO2 emissions (% of total fuel combustion) in 1962 in Italy to that in Japan?
Your answer should be very brief. 2.5. What is the ratio of the CO2 emissions (% of total fuel combustion) in 1963 in Italy to that in Japan?
Your answer should be very brief. 3.01. What is the ratio of the CO2 emissions (% of total fuel combustion) of 1960 in Italy to that in Luxembourg?
Provide a short and direct response. 3.77. What is the ratio of the CO2 emissions (% of total fuel combustion) of 1961 in Italy to that in Luxembourg?
Your answer should be compact. 3.3. What is the ratio of the CO2 emissions (% of total fuel combustion) of 1962 in Italy to that in Luxembourg?
Your answer should be compact. 2.88. What is the ratio of the CO2 emissions (% of total fuel combustion) of 1963 in Italy to that in Luxembourg?
Make the answer very short. 2.47. What is the ratio of the CO2 emissions (% of total fuel combustion) in 1960 in Italy to that in Netherlands?
Your response must be concise. 0.72. What is the ratio of the CO2 emissions (% of total fuel combustion) in 1961 in Italy to that in Netherlands?
Your answer should be very brief. 0.64. What is the ratio of the CO2 emissions (% of total fuel combustion) in 1963 in Italy to that in Netherlands?
Provide a succinct answer. 0.62. What is the ratio of the CO2 emissions (% of total fuel combustion) in 1960 in Japan to that in Luxembourg?
Give a very brief answer. 1.58. What is the ratio of the CO2 emissions (% of total fuel combustion) of 1961 in Japan to that in Luxembourg?
Give a very brief answer. 1.42. What is the ratio of the CO2 emissions (% of total fuel combustion) of 1962 in Japan to that in Luxembourg?
Offer a terse response. 1.15. What is the ratio of the CO2 emissions (% of total fuel combustion) in 1963 in Japan to that in Luxembourg?
Offer a terse response. 0.82. What is the ratio of the CO2 emissions (% of total fuel combustion) of 1960 in Japan to that in Netherlands?
Keep it short and to the point. 0.3. What is the ratio of the CO2 emissions (% of total fuel combustion) in 1961 in Japan to that in Netherlands?
Keep it short and to the point. 0.28. What is the ratio of the CO2 emissions (% of total fuel combustion) of 1962 in Japan to that in Netherlands?
Your answer should be compact. 0.25. What is the ratio of the CO2 emissions (% of total fuel combustion) in 1963 in Japan to that in Netherlands?
Your answer should be compact. 0.21. What is the ratio of the CO2 emissions (% of total fuel combustion) in 1960 in Luxembourg to that in Netherlands?
Ensure brevity in your answer.  0.19. What is the ratio of the CO2 emissions (% of total fuel combustion) in 1961 in Luxembourg to that in Netherlands?
Your answer should be compact. 0.2. What is the ratio of the CO2 emissions (% of total fuel combustion) in 1962 in Luxembourg to that in Netherlands?
Offer a terse response. 0.22. What is the ratio of the CO2 emissions (% of total fuel combustion) of 1963 in Luxembourg to that in Netherlands?
Keep it short and to the point. 0.25. What is the difference between the highest and the second highest CO2 emissions (% of total fuel combustion) in 1960?
Make the answer very short. 9.81. What is the difference between the highest and the second highest CO2 emissions (% of total fuel combustion) in 1961?
Provide a short and direct response. 9.67. What is the difference between the highest and the second highest CO2 emissions (% of total fuel combustion) of 1962?
Your response must be concise. 8.29. What is the difference between the highest and the second highest CO2 emissions (% of total fuel combustion) of 1963?
Make the answer very short. 5.68. What is the difference between the highest and the lowest CO2 emissions (% of total fuel combustion) of 1960?
Provide a succinct answer. 34.13. What is the difference between the highest and the lowest CO2 emissions (% of total fuel combustion) in 1961?
Your answer should be very brief. 36.04. What is the difference between the highest and the lowest CO2 emissions (% of total fuel combustion) of 1962?
Keep it short and to the point. 31.36. What is the difference between the highest and the lowest CO2 emissions (% of total fuel combustion) of 1963?
Your answer should be very brief. 30.68. 